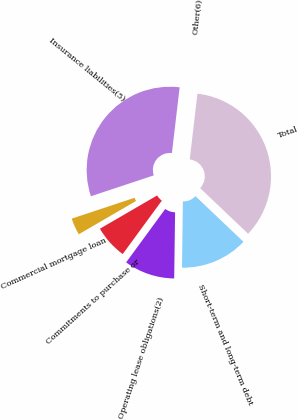Convert chart. <chart><loc_0><loc_0><loc_500><loc_500><pie_chart><fcel>Short-term and long-term debt<fcel>Operating lease obligations(2)<fcel>Commitments to purchase or<fcel>Commercial mortgage loan<fcel>Insurance liabilities(5)<fcel>Other(6)<fcel>Total<nl><fcel>13.12%<fcel>9.84%<fcel>6.56%<fcel>3.28%<fcel>31.96%<fcel>0.0%<fcel>35.24%<nl></chart> 